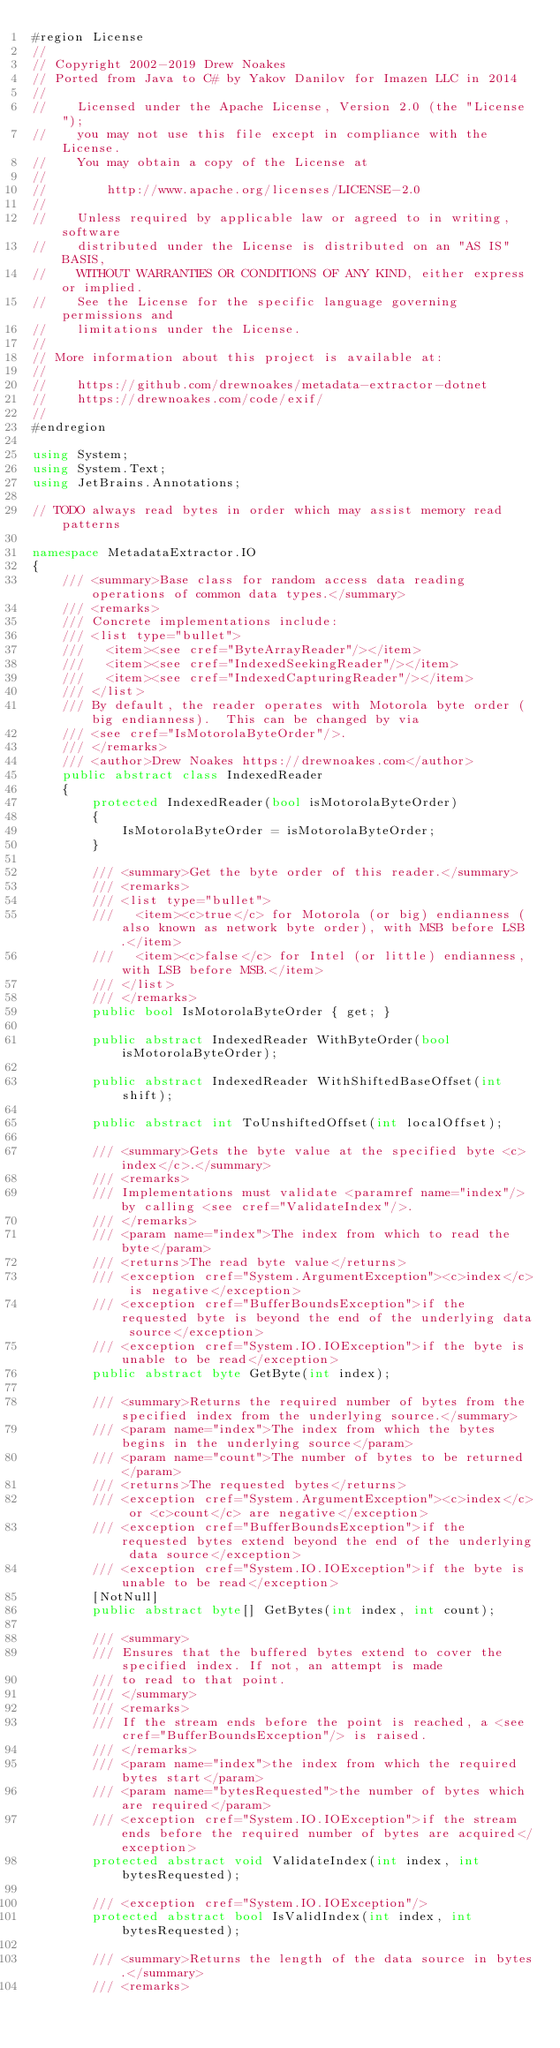<code> <loc_0><loc_0><loc_500><loc_500><_C#_>#region License
//
// Copyright 2002-2019 Drew Noakes
// Ported from Java to C# by Yakov Danilov for Imazen LLC in 2014
//
//    Licensed under the Apache License, Version 2.0 (the "License");
//    you may not use this file except in compliance with the License.
//    You may obtain a copy of the License at
//
//        http://www.apache.org/licenses/LICENSE-2.0
//
//    Unless required by applicable law or agreed to in writing, software
//    distributed under the License is distributed on an "AS IS" BASIS,
//    WITHOUT WARRANTIES OR CONDITIONS OF ANY KIND, either express or implied.
//    See the License for the specific language governing permissions and
//    limitations under the License.
//
// More information about this project is available at:
//
//    https://github.com/drewnoakes/metadata-extractor-dotnet
//    https://drewnoakes.com/code/exif/
//
#endregion

using System;
using System.Text;
using JetBrains.Annotations;

// TODO always read bytes in order which may assist memory read patterns

namespace MetadataExtractor.IO
{
    /// <summary>Base class for random access data reading operations of common data types.</summary>
    /// <remarks>
    /// Concrete implementations include:
    /// <list type="bullet">
    ///   <item><see cref="ByteArrayReader"/></item>
    ///   <item><see cref="IndexedSeekingReader"/></item>
    ///   <item><see cref="IndexedCapturingReader"/></item>
    /// </list>
    /// By default, the reader operates with Motorola byte order (big endianness).  This can be changed by via
    /// <see cref="IsMotorolaByteOrder"/>.
    /// </remarks>
    /// <author>Drew Noakes https://drewnoakes.com</author>
    public abstract class IndexedReader
    {
        protected IndexedReader(bool isMotorolaByteOrder)
        {
            IsMotorolaByteOrder = isMotorolaByteOrder;
        }

        /// <summary>Get the byte order of this reader.</summary>
        /// <remarks>
        /// <list type="bullet">
        ///   <item><c>true</c> for Motorola (or big) endianness (also known as network byte order), with MSB before LSB.</item>
        ///   <item><c>false</c> for Intel (or little) endianness, with LSB before MSB.</item>
        /// </list>
        /// </remarks>
        public bool IsMotorolaByteOrder { get; }

        public abstract IndexedReader WithByteOrder(bool isMotorolaByteOrder);

        public abstract IndexedReader WithShiftedBaseOffset(int shift);

        public abstract int ToUnshiftedOffset(int localOffset);

        /// <summary>Gets the byte value at the specified byte <c>index</c>.</summary>
        /// <remarks>
        /// Implementations must validate <paramref name="index"/> by calling <see cref="ValidateIndex"/>.
        /// </remarks>
        /// <param name="index">The index from which to read the byte</param>
        /// <returns>The read byte value</returns>
        /// <exception cref="System.ArgumentException"><c>index</c> is negative</exception>
        /// <exception cref="BufferBoundsException">if the requested byte is beyond the end of the underlying data source</exception>
        /// <exception cref="System.IO.IOException">if the byte is unable to be read</exception>
        public abstract byte GetByte(int index);

        /// <summary>Returns the required number of bytes from the specified index from the underlying source.</summary>
        /// <param name="index">The index from which the bytes begins in the underlying source</param>
        /// <param name="count">The number of bytes to be returned</param>
        /// <returns>The requested bytes</returns>
        /// <exception cref="System.ArgumentException"><c>index</c> or <c>count</c> are negative</exception>
        /// <exception cref="BufferBoundsException">if the requested bytes extend beyond the end of the underlying data source</exception>
        /// <exception cref="System.IO.IOException">if the byte is unable to be read</exception>
        [NotNull]
        public abstract byte[] GetBytes(int index, int count);

        /// <summary>
        /// Ensures that the buffered bytes extend to cover the specified index. If not, an attempt is made
        /// to read to that point.
        /// </summary>
        /// <remarks>
        /// If the stream ends before the point is reached, a <see cref="BufferBoundsException"/> is raised.
        /// </remarks>
        /// <param name="index">the index from which the required bytes start</param>
        /// <param name="bytesRequested">the number of bytes which are required</param>
        /// <exception cref="System.IO.IOException">if the stream ends before the required number of bytes are acquired</exception>
        protected abstract void ValidateIndex(int index, int bytesRequested);

        /// <exception cref="System.IO.IOException"/>
        protected abstract bool IsValidIndex(int index, int bytesRequested);

        /// <summary>Returns the length of the data source in bytes.</summary>
        /// <remarks></code> 